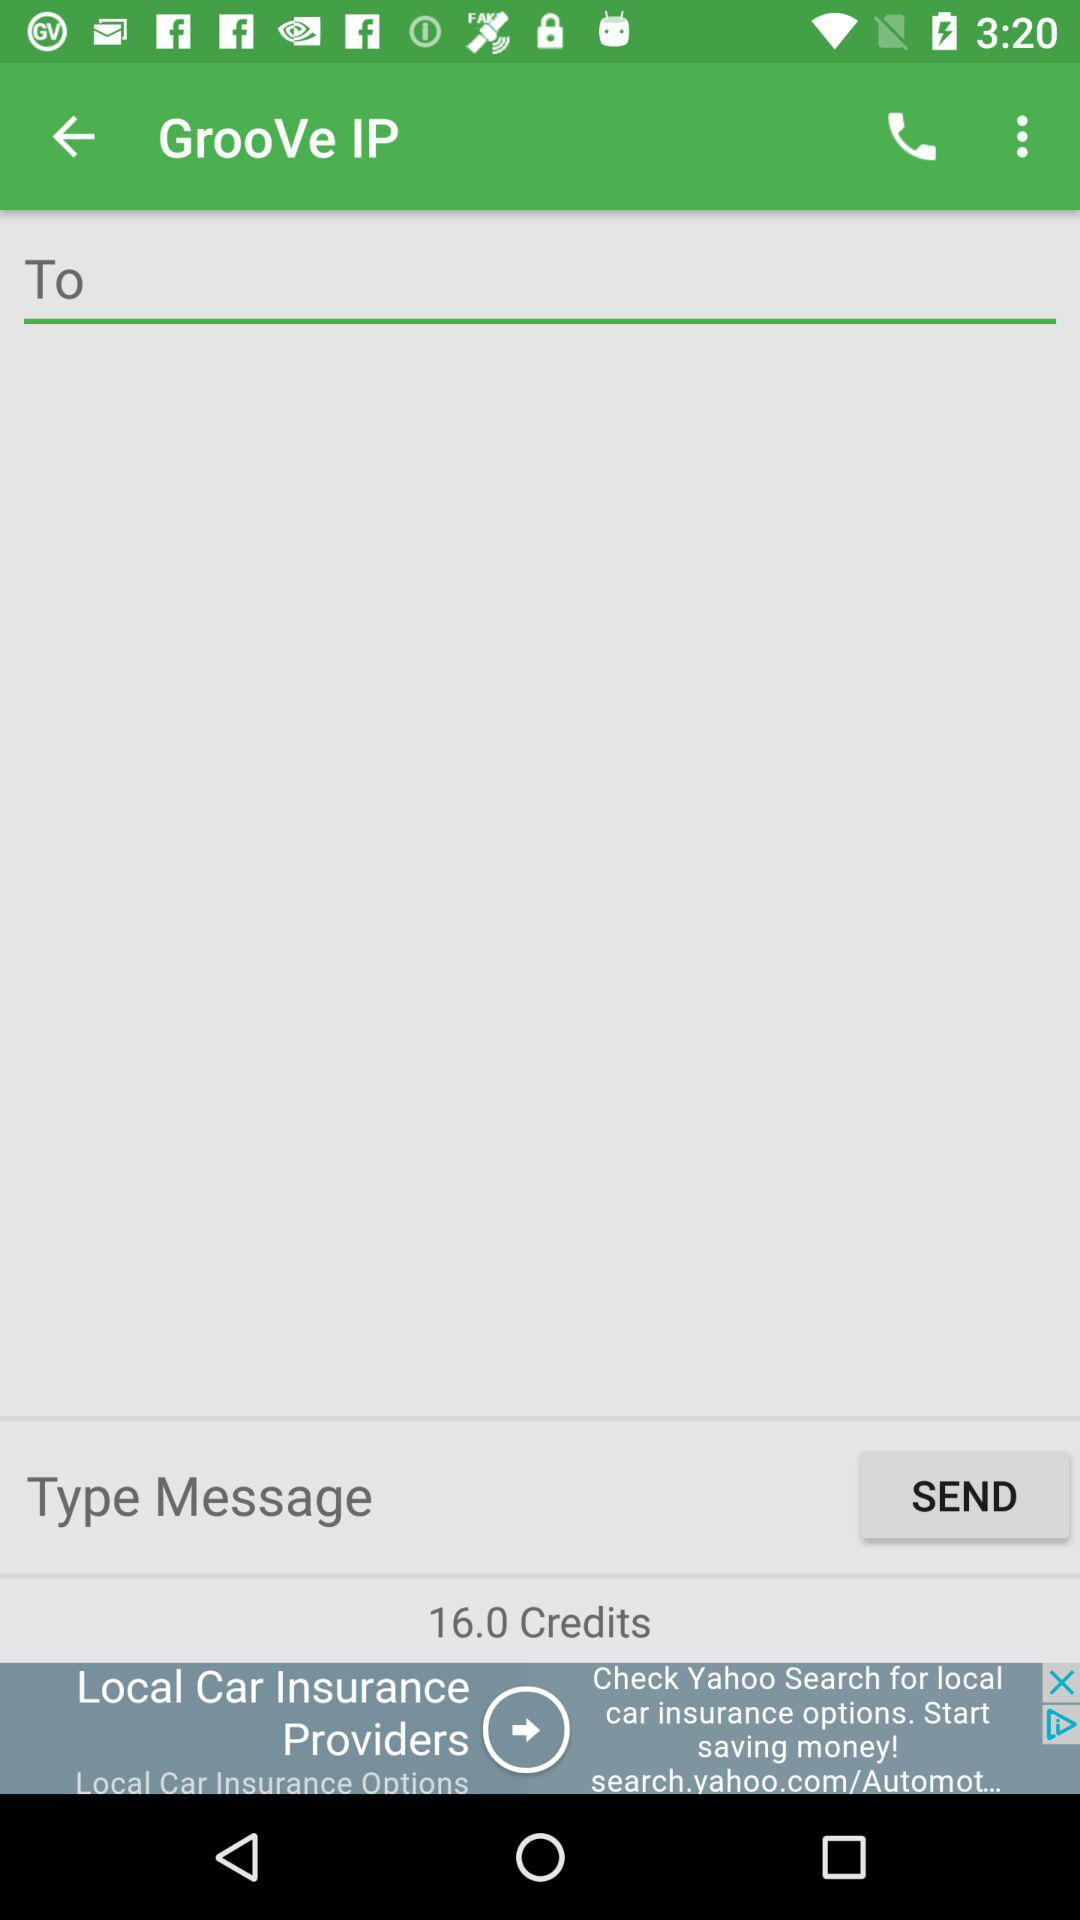How many credits do I have?
Answer the question using a single word or phrase. 16.0 